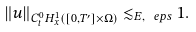<formula> <loc_0><loc_0><loc_500><loc_500>\| u \| _ { C ^ { 0 } _ { t } H ^ { 1 } _ { x } ( [ 0 , T ^ { \prime } ] \times \Omega ) } \lesssim _ { E , \ e p s } 1 .</formula> 